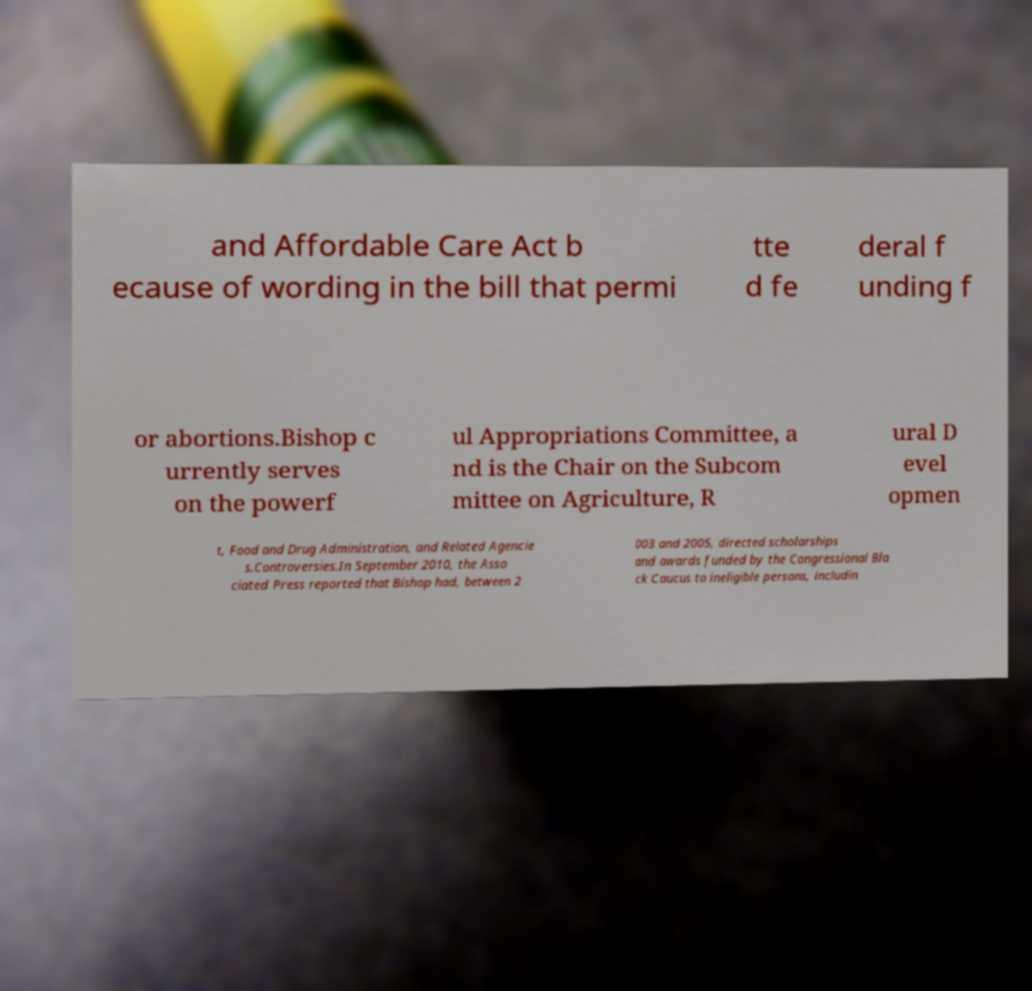Can you read and provide the text displayed in the image?This photo seems to have some interesting text. Can you extract and type it out for me? and Affordable Care Act b ecause of wording in the bill that permi tte d fe deral f unding f or abortions.Bishop c urrently serves on the powerf ul Appropriations Committee, a nd is the Chair on the Subcom mittee on Agriculture, R ural D evel opmen t, Food and Drug Administration, and Related Agencie s.Controversies.In September 2010, the Asso ciated Press reported that Bishop had, between 2 003 and 2005, directed scholarships and awards funded by the Congressional Bla ck Caucus to ineligible persons, includin 